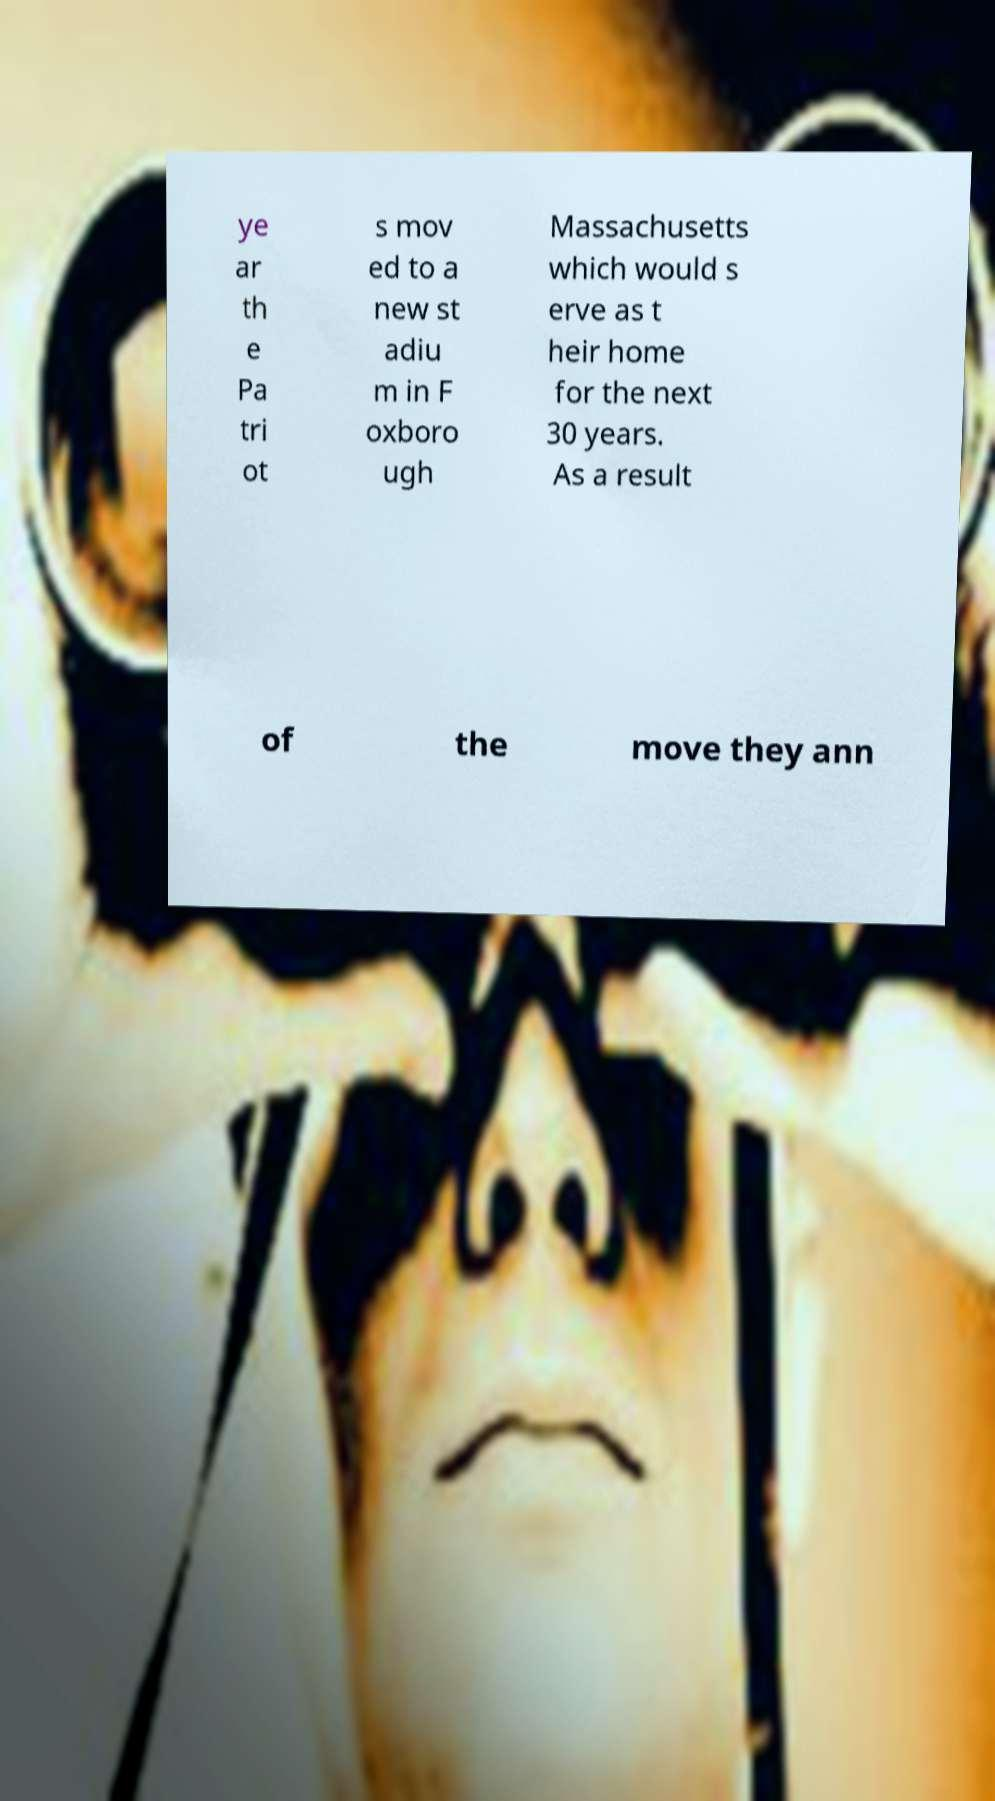Please read and relay the text visible in this image. What does it say? ye ar th e Pa tri ot s mov ed to a new st adiu m in F oxboro ugh Massachusetts which would s erve as t heir home for the next 30 years. As a result of the move they ann 